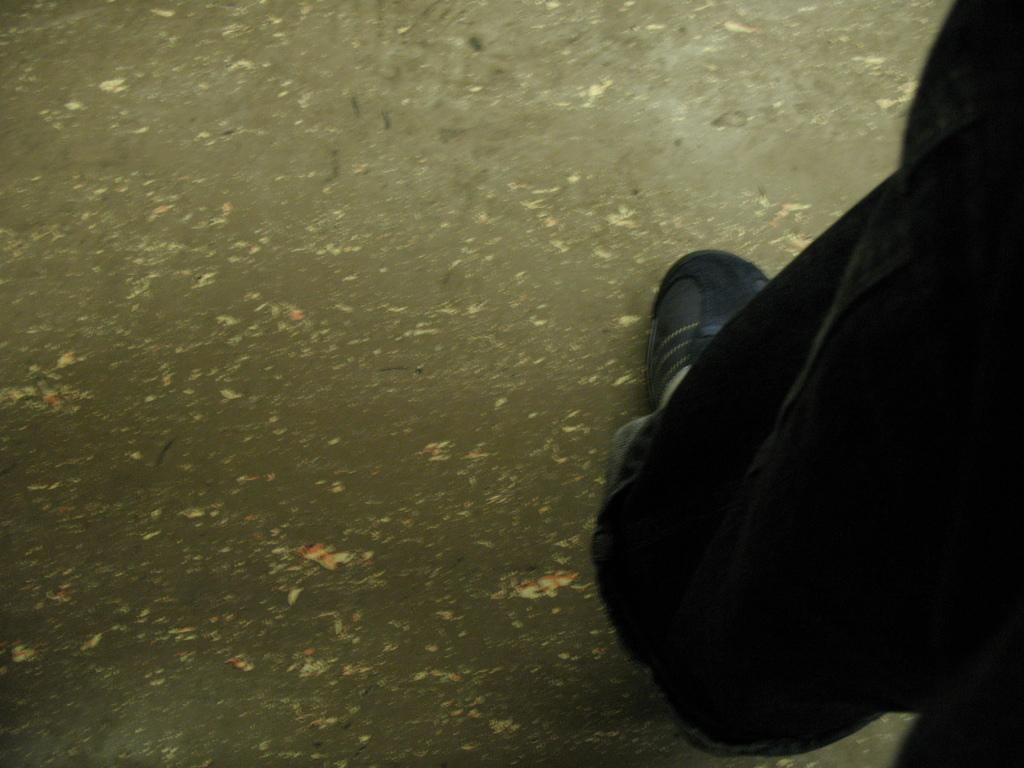How would you summarize this image in a sentence or two? As we can see in the image on the right side there is a person wearing black color shoe. 